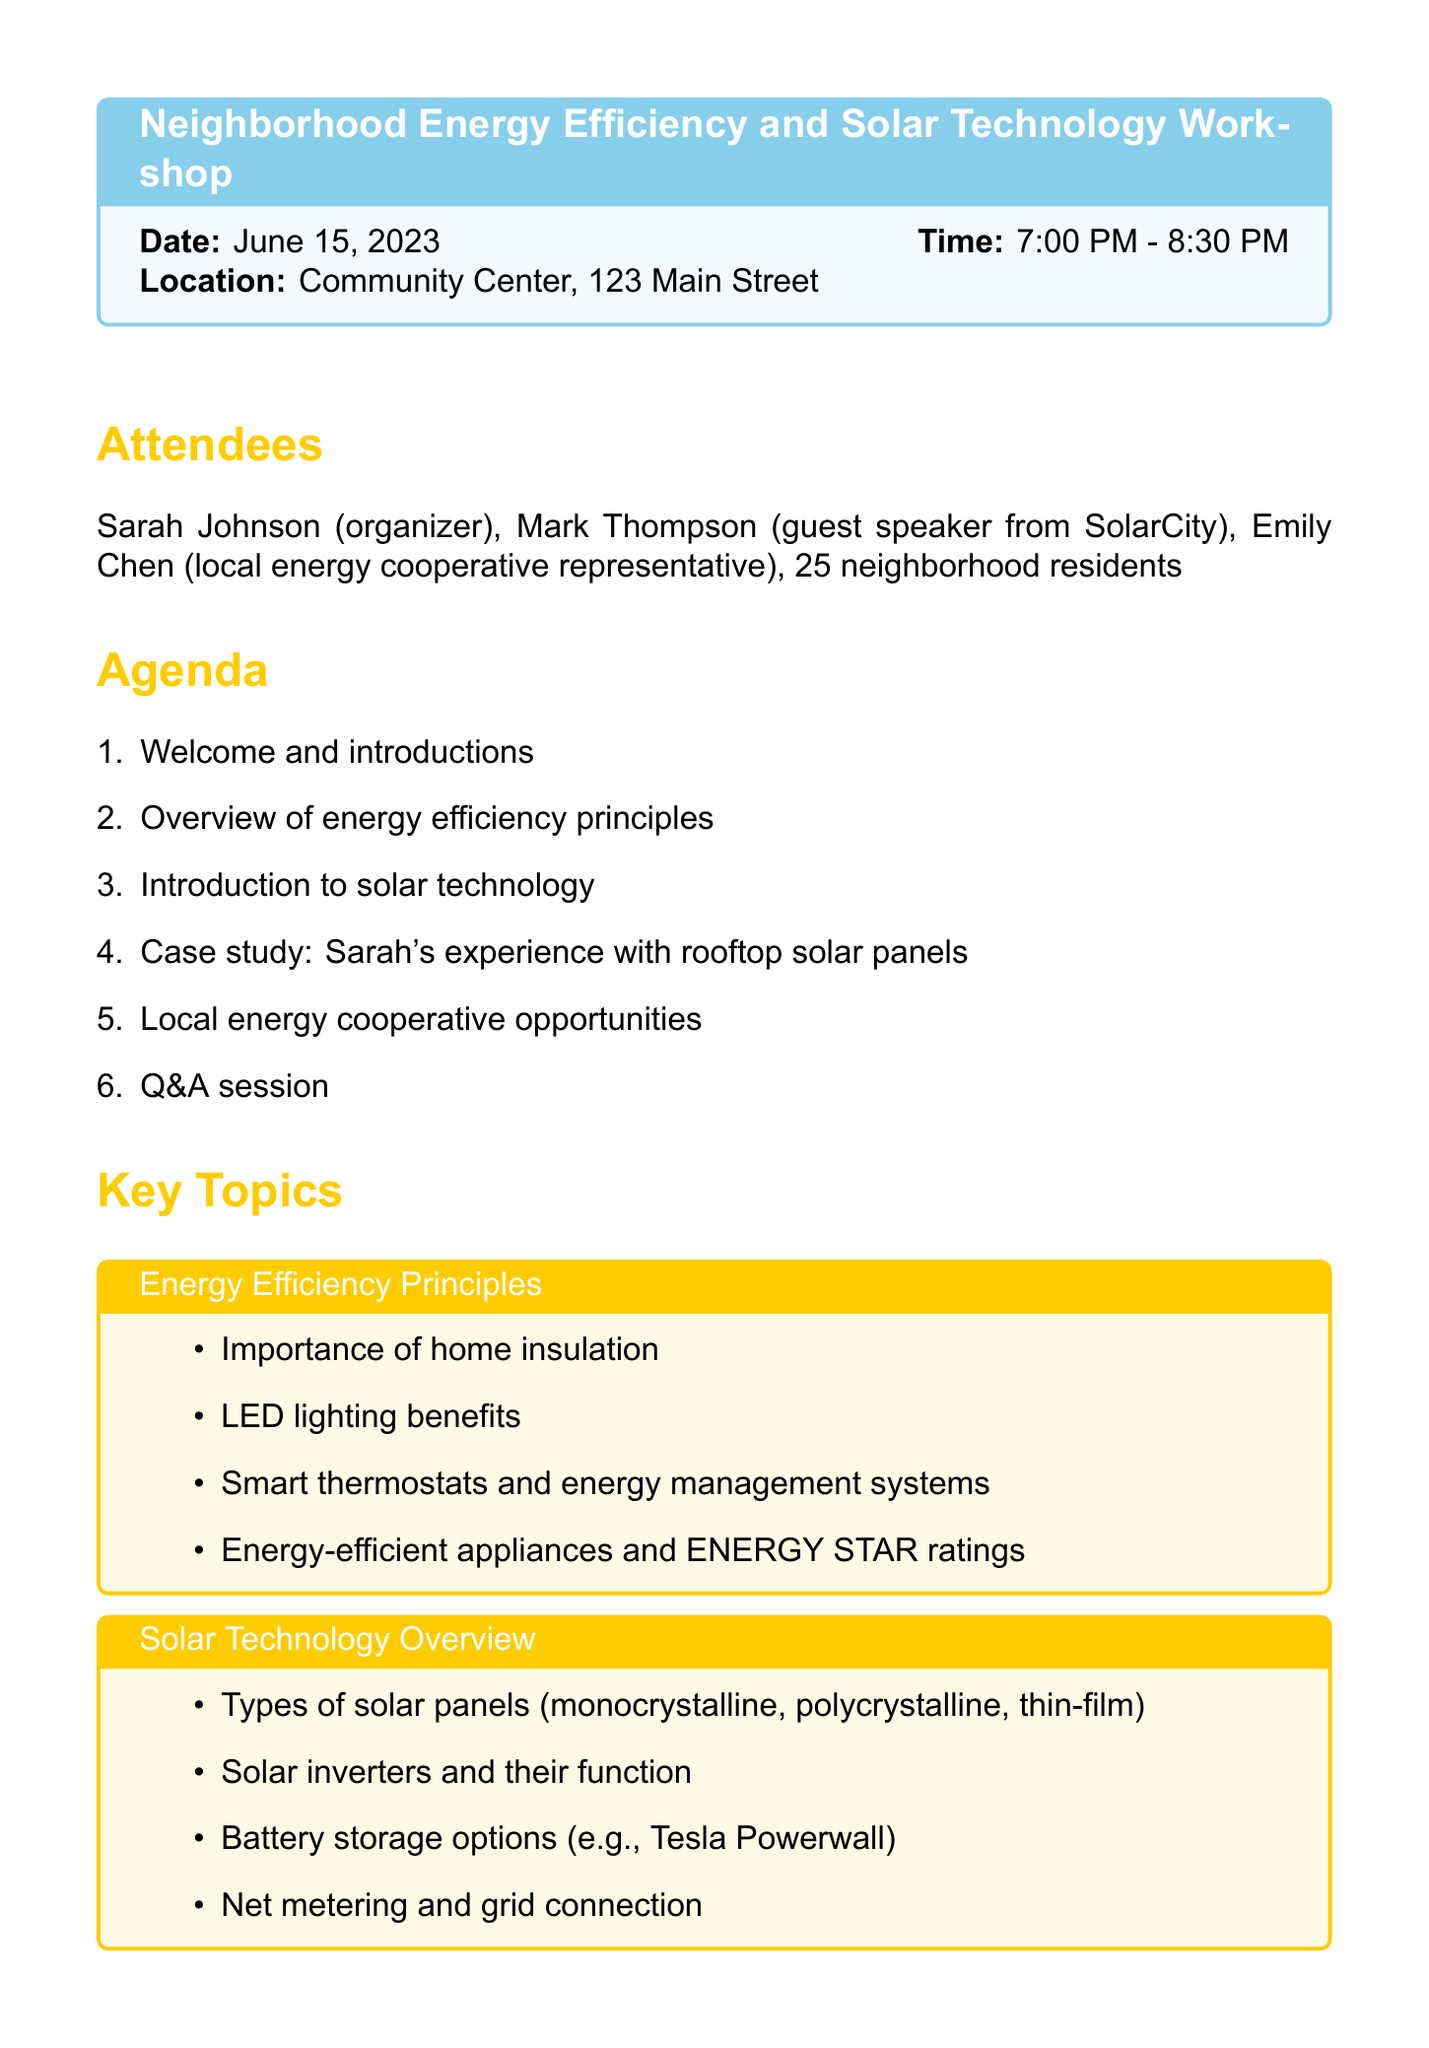What is the date of the workshop? The date of the workshop is mentioned at the beginning of the document.
Answer: June 15, 2023 Who is the guest speaker from SolarCity? The document lists Mark Thompson as the guest speaker from SolarCity.
Answer: Mark Thompson What time does the workshop start? The starting time of the workshop is clearly stated in the document.
Answer: 7:00 PM What is one action item listed in the document? The document includes several action items for follow-up, one of which is highlighted in the action items section.
Answer: Distribute energy efficiency checklists to attendees How many attendees were there? The document specifies the total number of neighborhood residents attending the workshop.
Answer: 25 neighborhood residents What is one topic discussed about solar technology? The key topics section outlines various points, one of which is related to solar technology.
Answer: Types of solar panels (monocrystalline, polycrystalline, thin-film) What will the next meeting topic be about? The document outlines the topic for the next meeting at the end.
Answer: Community Solar Project Planning What percentage of the agenda is dedicated to Q&A? The agenda lists the items, including a Q&A session as the final point.
Answer: Approximately 16.67% (1 out of 6 agenda items) 